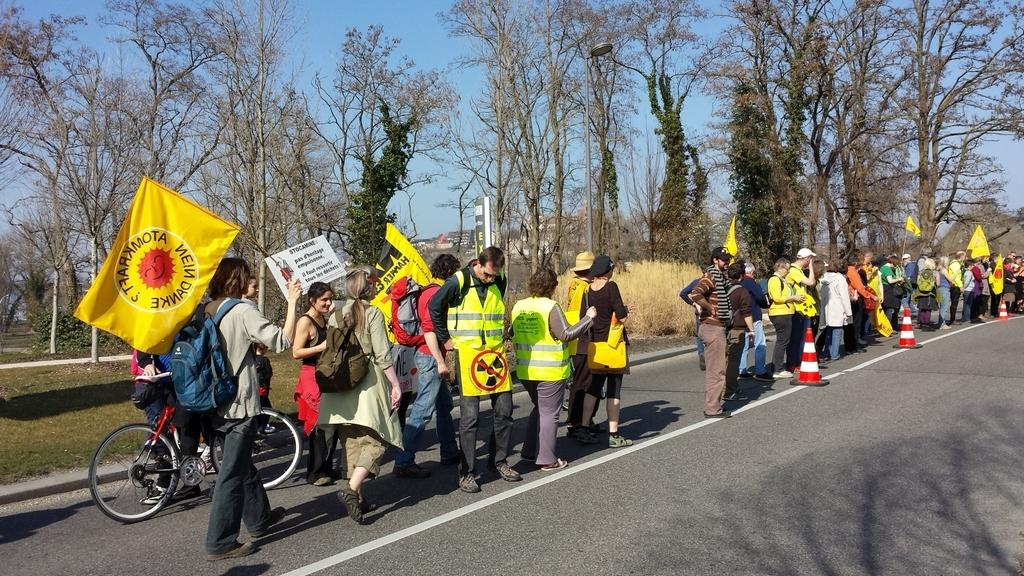What are the people in the image doing? The people in the image are standing on a road. What objects are the people holding in their hands? The people are holding flags in their hands. What can be seen in the background of the image? There are trees in the background of the image. What type of plastic objects can be seen being smashed by the people in the image? There are no plastic objects being smashed in the image; the people are holding flags. What type of clouds can be seen in the image? There is no mention of clouds in the provided facts, so we cannot determine if any clouds are present in the image. 